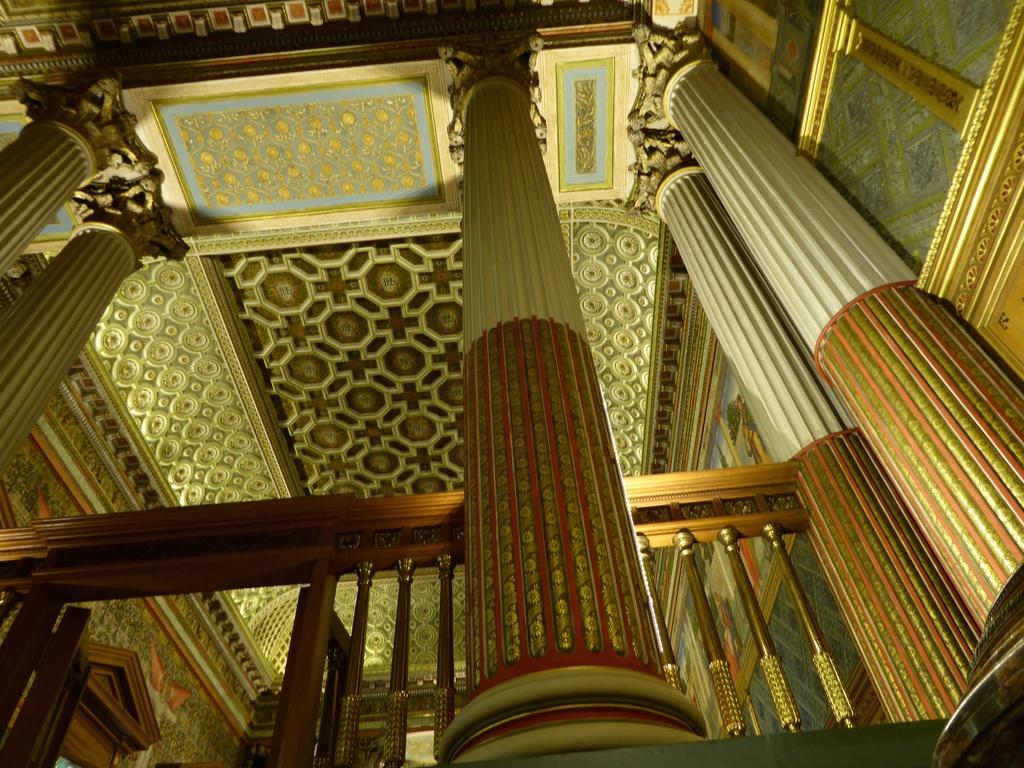What architectural features can be seen in the image? There are pillars and railing in the image. What part of a building is visible at the top of the image? The roof of a building is visible at the top of the image. Where was the image taken? The image was taken inside a building. What is the opinion of the pillars in the image? The image does not express an opinion about the pillars; it simply shows their presence. 